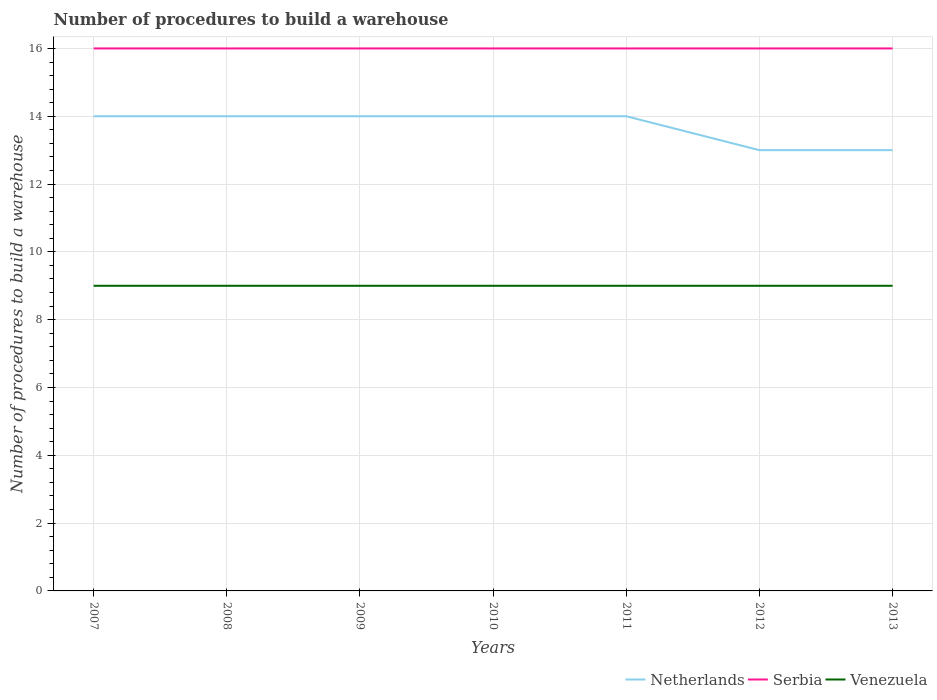Does the line corresponding to Netherlands intersect with the line corresponding to Venezuela?
Make the answer very short. No. Is the number of lines equal to the number of legend labels?
Keep it short and to the point. Yes. Across all years, what is the maximum number of procedures to build a warehouse in in Venezuela?
Provide a short and direct response. 9. What is the total number of procedures to build a warehouse in in Venezuela in the graph?
Your answer should be compact. 0. What is the difference between the highest and the second highest number of procedures to build a warehouse in in Netherlands?
Make the answer very short. 1. What is the difference between the highest and the lowest number of procedures to build a warehouse in in Venezuela?
Give a very brief answer. 0. What is the title of the graph?
Make the answer very short. Number of procedures to build a warehouse. Does "Cuba" appear as one of the legend labels in the graph?
Give a very brief answer. No. What is the label or title of the X-axis?
Your answer should be compact. Years. What is the label or title of the Y-axis?
Provide a short and direct response. Number of procedures to build a warehouse. What is the Number of procedures to build a warehouse of Netherlands in 2007?
Keep it short and to the point. 14. What is the Number of procedures to build a warehouse in Serbia in 2007?
Provide a succinct answer. 16. What is the Number of procedures to build a warehouse in Venezuela in 2007?
Offer a terse response. 9. What is the Number of procedures to build a warehouse in Netherlands in 2008?
Keep it short and to the point. 14. What is the Number of procedures to build a warehouse in Venezuela in 2008?
Keep it short and to the point. 9. What is the Number of procedures to build a warehouse of Netherlands in 2009?
Provide a short and direct response. 14. What is the Number of procedures to build a warehouse of Serbia in 2009?
Keep it short and to the point. 16. What is the Number of procedures to build a warehouse in Venezuela in 2009?
Offer a terse response. 9. What is the Number of procedures to build a warehouse in Netherlands in 2010?
Provide a short and direct response. 14. What is the Number of procedures to build a warehouse of Serbia in 2010?
Keep it short and to the point. 16. What is the Number of procedures to build a warehouse in Netherlands in 2011?
Keep it short and to the point. 14. What is the Number of procedures to build a warehouse of Serbia in 2011?
Offer a terse response. 16. What is the Number of procedures to build a warehouse of Serbia in 2013?
Give a very brief answer. 16. Across all years, what is the maximum Number of procedures to build a warehouse in Netherlands?
Give a very brief answer. 14. Across all years, what is the maximum Number of procedures to build a warehouse of Serbia?
Your answer should be compact. 16. Across all years, what is the maximum Number of procedures to build a warehouse of Venezuela?
Your answer should be compact. 9. Across all years, what is the minimum Number of procedures to build a warehouse in Netherlands?
Offer a very short reply. 13. Across all years, what is the minimum Number of procedures to build a warehouse of Serbia?
Ensure brevity in your answer.  16. What is the total Number of procedures to build a warehouse in Netherlands in the graph?
Provide a short and direct response. 96. What is the total Number of procedures to build a warehouse in Serbia in the graph?
Ensure brevity in your answer.  112. What is the difference between the Number of procedures to build a warehouse in Netherlands in 2007 and that in 2008?
Offer a terse response. 0. What is the difference between the Number of procedures to build a warehouse of Serbia in 2007 and that in 2008?
Give a very brief answer. 0. What is the difference between the Number of procedures to build a warehouse of Venezuela in 2007 and that in 2008?
Offer a terse response. 0. What is the difference between the Number of procedures to build a warehouse in Venezuela in 2007 and that in 2009?
Your answer should be very brief. 0. What is the difference between the Number of procedures to build a warehouse in Netherlands in 2007 and that in 2010?
Your response must be concise. 0. What is the difference between the Number of procedures to build a warehouse in Serbia in 2007 and that in 2011?
Give a very brief answer. 0. What is the difference between the Number of procedures to build a warehouse in Serbia in 2007 and that in 2012?
Keep it short and to the point. 0. What is the difference between the Number of procedures to build a warehouse of Netherlands in 2007 and that in 2013?
Make the answer very short. 1. What is the difference between the Number of procedures to build a warehouse of Serbia in 2007 and that in 2013?
Keep it short and to the point. 0. What is the difference between the Number of procedures to build a warehouse of Netherlands in 2008 and that in 2009?
Provide a succinct answer. 0. What is the difference between the Number of procedures to build a warehouse in Venezuela in 2008 and that in 2009?
Offer a terse response. 0. What is the difference between the Number of procedures to build a warehouse of Serbia in 2008 and that in 2010?
Provide a short and direct response. 0. What is the difference between the Number of procedures to build a warehouse of Serbia in 2008 and that in 2011?
Give a very brief answer. 0. What is the difference between the Number of procedures to build a warehouse of Netherlands in 2008 and that in 2012?
Give a very brief answer. 1. What is the difference between the Number of procedures to build a warehouse of Serbia in 2008 and that in 2012?
Make the answer very short. 0. What is the difference between the Number of procedures to build a warehouse of Serbia in 2009 and that in 2010?
Provide a short and direct response. 0. What is the difference between the Number of procedures to build a warehouse of Netherlands in 2009 and that in 2012?
Give a very brief answer. 1. What is the difference between the Number of procedures to build a warehouse of Netherlands in 2009 and that in 2013?
Your response must be concise. 1. What is the difference between the Number of procedures to build a warehouse in Serbia in 2009 and that in 2013?
Your answer should be compact. 0. What is the difference between the Number of procedures to build a warehouse of Venezuela in 2009 and that in 2013?
Offer a terse response. 0. What is the difference between the Number of procedures to build a warehouse in Netherlands in 2010 and that in 2011?
Provide a short and direct response. 0. What is the difference between the Number of procedures to build a warehouse in Netherlands in 2010 and that in 2012?
Provide a short and direct response. 1. What is the difference between the Number of procedures to build a warehouse in Serbia in 2010 and that in 2012?
Make the answer very short. 0. What is the difference between the Number of procedures to build a warehouse in Venezuela in 2010 and that in 2012?
Your response must be concise. 0. What is the difference between the Number of procedures to build a warehouse of Netherlands in 2010 and that in 2013?
Offer a very short reply. 1. What is the difference between the Number of procedures to build a warehouse of Venezuela in 2010 and that in 2013?
Keep it short and to the point. 0. What is the difference between the Number of procedures to build a warehouse of Serbia in 2011 and that in 2013?
Provide a short and direct response. 0. What is the difference between the Number of procedures to build a warehouse of Venezuela in 2011 and that in 2013?
Your answer should be very brief. 0. What is the difference between the Number of procedures to build a warehouse in Netherlands in 2012 and that in 2013?
Provide a short and direct response. 0. What is the difference between the Number of procedures to build a warehouse in Serbia in 2012 and that in 2013?
Your answer should be compact. 0. What is the difference between the Number of procedures to build a warehouse of Netherlands in 2007 and the Number of procedures to build a warehouse of Serbia in 2009?
Your answer should be very brief. -2. What is the difference between the Number of procedures to build a warehouse in Netherlands in 2007 and the Number of procedures to build a warehouse in Venezuela in 2010?
Ensure brevity in your answer.  5. What is the difference between the Number of procedures to build a warehouse of Serbia in 2007 and the Number of procedures to build a warehouse of Venezuela in 2010?
Your answer should be very brief. 7. What is the difference between the Number of procedures to build a warehouse in Netherlands in 2007 and the Number of procedures to build a warehouse in Venezuela in 2011?
Offer a terse response. 5. What is the difference between the Number of procedures to build a warehouse of Netherlands in 2007 and the Number of procedures to build a warehouse of Serbia in 2012?
Provide a short and direct response. -2. What is the difference between the Number of procedures to build a warehouse in Netherlands in 2007 and the Number of procedures to build a warehouse in Venezuela in 2012?
Offer a very short reply. 5. What is the difference between the Number of procedures to build a warehouse in Netherlands in 2007 and the Number of procedures to build a warehouse in Serbia in 2013?
Provide a short and direct response. -2. What is the difference between the Number of procedures to build a warehouse of Netherlands in 2007 and the Number of procedures to build a warehouse of Venezuela in 2013?
Give a very brief answer. 5. What is the difference between the Number of procedures to build a warehouse of Serbia in 2007 and the Number of procedures to build a warehouse of Venezuela in 2013?
Your answer should be compact. 7. What is the difference between the Number of procedures to build a warehouse in Serbia in 2008 and the Number of procedures to build a warehouse in Venezuela in 2009?
Your answer should be very brief. 7. What is the difference between the Number of procedures to build a warehouse in Netherlands in 2008 and the Number of procedures to build a warehouse in Serbia in 2010?
Your answer should be very brief. -2. What is the difference between the Number of procedures to build a warehouse in Serbia in 2008 and the Number of procedures to build a warehouse in Venezuela in 2010?
Keep it short and to the point. 7. What is the difference between the Number of procedures to build a warehouse in Netherlands in 2008 and the Number of procedures to build a warehouse in Venezuela in 2011?
Provide a succinct answer. 5. What is the difference between the Number of procedures to build a warehouse in Serbia in 2008 and the Number of procedures to build a warehouse in Venezuela in 2011?
Provide a short and direct response. 7. What is the difference between the Number of procedures to build a warehouse of Netherlands in 2008 and the Number of procedures to build a warehouse of Serbia in 2013?
Provide a short and direct response. -2. What is the difference between the Number of procedures to build a warehouse of Netherlands in 2009 and the Number of procedures to build a warehouse of Venezuela in 2010?
Provide a succinct answer. 5. What is the difference between the Number of procedures to build a warehouse in Netherlands in 2009 and the Number of procedures to build a warehouse in Serbia in 2011?
Your answer should be very brief. -2. What is the difference between the Number of procedures to build a warehouse of Netherlands in 2009 and the Number of procedures to build a warehouse of Venezuela in 2011?
Give a very brief answer. 5. What is the difference between the Number of procedures to build a warehouse of Netherlands in 2009 and the Number of procedures to build a warehouse of Serbia in 2013?
Your answer should be very brief. -2. What is the difference between the Number of procedures to build a warehouse of Serbia in 2010 and the Number of procedures to build a warehouse of Venezuela in 2011?
Keep it short and to the point. 7. What is the difference between the Number of procedures to build a warehouse of Netherlands in 2010 and the Number of procedures to build a warehouse of Venezuela in 2012?
Your response must be concise. 5. What is the difference between the Number of procedures to build a warehouse in Serbia in 2010 and the Number of procedures to build a warehouse in Venezuela in 2012?
Your answer should be compact. 7. What is the difference between the Number of procedures to build a warehouse in Netherlands in 2010 and the Number of procedures to build a warehouse in Venezuela in 2013?
Provide a short and direct response. 5. What is the difference between the Number of procedures to build a warehouse in Netherlands in 2011 and the Number of procedures to build a warehouse in Venezuela in 2012?
Keep it short and to the point. 5. What is the difference between the Number of procedures to build a warehouse of Netherlands in 2011 and the Number of procedures to build a warehouse of Venezuela in 2013?
Make the answer very short. 5. What is the average Number of procedures to build a warehouse of Netherlands per year?
Ensure brevity in your answer.  13.71. In the year 2007, what is the difference between the Number of procedures to build a warehouse of Serbia and Number of procedures to build a warehouse of Venezuela?
Ensure brevity in your answer.  7. In the year 2008, what is the difference between the Number of procedures to build a warehouse in Serbia and Number of procedures to build a warehouse in Venezuela?
Your answer should be very brief. 7. In the year 2010, what is the difference between the Number of procedures to build a warehouse in Serbia and Number of procedures to build a warehouse in Venezuela?
Keep it short and to the point. 7. In the year 2011, what is the difference between the Number of procedures to build a warehouse in Netherlands and Number of procedures to build a warehouse in Serbia?
Your answer should be compact. -2. In the year 2011, what is the difference between the Number of procedures to build a warehouse of Serbia and Number of procedures to build a warehouse of Venezuela?
Give a very brief answer. 7. In the year 2012, what is the difference between the Number of procedures to build a warehouse of Netherlands and Number of procedures to build a warehouse of Serbia?
Provide a short and direct response. -3. In the year 2012, what is the difference between the Number of procedures to build a warehouse in Netherlands and Number of procedures to build a warehouse in Venezuela?
Offer a very short reply. 4. In the year 2012, what is the difference between the Number of procedures to build a warehouse in Serbia and Number of procedures to build a warehouse in Venezuela?
Make the answer very short. 7. In the year 2013, what is the difference between the Number of procedures to build a warehouse of Netherlands and Number of procedures to build a warehouse of Serbia?
Keep it short and to the point. -3. In the year 2013, what is the difference between the Number of procedures to build a warehouse in Serbia and Number of procedures to build a warehouse in Venezuela?
Your answer should be very brief. 7. What is the ratio of the Number of procedures to build a warehouse of Netherlands in 2007 to that in 2009?
Offer a terse response. 1. What is the ratio of the Number of procedures to build a warehouse of Serbia in 2007 to that in 2009?
Provide a succinct answer. 1. What is the ratio of the Number of procedures to build a warehouse of Venezuela in 2007 to that in 2009?
Keep it short and to the point. 1. What is the ratio of the Number of procedures to build a warehouse of Netherlands in 2007 to that in 2010?
Provide a short and direct response. 1. What is the ratio of the Number of procedures to build a warehouse in Serbia in 2007 to that in 2010?
Provide a short and direct response. 1. What is the ratio of the Number of procedures to build a warehouse of Venezuela in 2007 to that in 2010?
Offer a terse response. 1. What is the ratio of the Number of procedures to build a warehouse of Venezuela in 2007 to that in 2011?
Give a very brief answer. 1. What is the ratio of the Number of procedures to build a warehouse in Netherlands in 2007 to that in 2012?
Your answer should be compact. 1.08. What is the ratio of the Number of procedures to build a warehouse of Serbia in 2007 to that in 2012?
Ensure brevity in your answer.  1. What is the ratio of the Number of procedures to build a warehouse of Venezuela in 2007 to that in 2012?
Make the answer very short. 1. What is the ratio of the Number of procedures to build a warehouse of Netherlands in 2008 to that in 2009?
Give a very brief answer. 1. What is the ratio of the Number of procedures to build a warehouse in Venezuela in 2008 to that in 2010?
Your response must be concise. 1. What is the ratio of the Number of procedures to build a warehouse in Netherlands in 2008 to that in 2011?
Give a very brief answer. 1. What is the ratio of the Number of procedures to build a warehouse of Venezuela in 2008 to that in 2011?
Provide a short and direct response. 1. What is the ratio of the Number of procedures to build a warehouse in Netherlands in 2008 to that in 2012?
Provide a short and direct response. 1.08. What is the ratio of the Number of procedures to build a warehouse in Venezuela in 2008 to that in 2012?
Your answer should be very brief. 1. What is the ratio of the Number of procedures to build a warehouse in Serbia in 2008 to that in 2013?
Your response must be concise. 1. What is the ratio of the Number of procedures to build a warehouse in Netherlands in 2009 to that in 2010?
Make the answer very short. 1. What is the ratio of the Number of procedures to build a warehouse in Serbia in 2009 to that in 2010?
Keep it short and to the point. 1. What is the ratio of the Number of procedures to build a warehouse in Netherlands in 2009 to that in 2011?
Provide a short and direct response. 1. What is the ratio of the Number of procedures to build a warehouse in Serbia in 2009 to that in 2011?
Your response must be concise. 1. What is the ratio of the Number of procedures to build a warehouse of Venezuela in 2009 to that in 2011?
Keep it short and to the point. 1. What is the ratio of the Number of procedures to build a warehouse in Netherlands in 2009 to that in 2012?
Your answer should be compact. 1.08. What is the ratio of the Number of procedures to build a warehouse of Serbia in 2009 to that in 2012?
Offer a terse response. 1. What is the ratio of the Number of procedures to build a warehouse in Netherlands in 2009 to that in 2013?
Keep it short and to the point. 1.08. What is the ratio of the Number of procedures to build a warehouse in Serbia in 2009 to that in 2013?
Offer a terse response. 1. What is the ratio of the Number of procedures to build a warehouse in Venezuela in 2009 to that in 2013?
Keep it short and to the point. 1. What is the ratio of the Number of procedures to build a warehouse of Netherlands in 2010 to that in 2011?
Offer a very short reply. 1. What is the ratio of the Number of procedures to build a warehouse of Serbia in 2010 to that in 2011?
Provide a succinct answer. 1. What is the ratio of the Number of procedures to build a warehouse of Venezuela in 2010 to that in 2011?
Offer a terse response. 1. What is the ratio of the Number of procedures to build a warehouse of Serbia in 2010 to that in 2013?
Provide a short and direct response. 1. What is the ratio of the Number of procedures to build a warehouse of Venezuela in 2010 to that in 2013?
Offer a terse response. 1. What is the ratio of the Number of procedures to build a warehouse in Netherlands in 2011 to that in 2013?
Offer a very short reply. 1.08. What is the ratio of the Number of procedures to build a warehouse in Serbia in 2011 to that in 2013?
Ensure brevity in your answer.  1. What is the ratio of the Number of procedures to build a warehouse of Netherlands in 2012 to that in 2013?
Your answer should be compact. 1. What is the difference between the highest and the second highest Number of procedures to build a warehouse of Venezuela?
Your response must be concise. 0. What is the difference between the highest and the lowest Number of procedures to build a warehouse in Netherlands?
Provide a succinct answer. 1. 